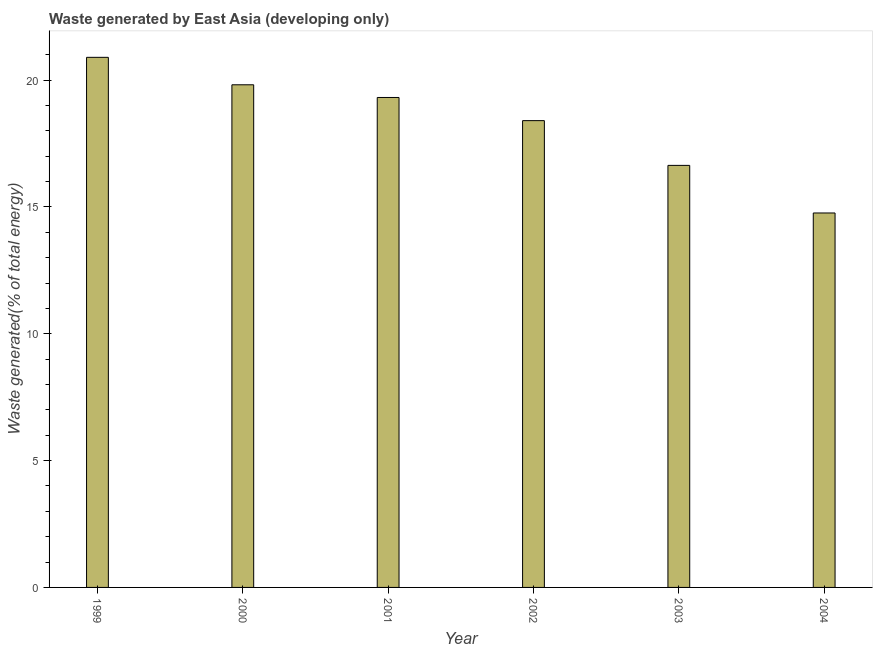What is the title of the graph?
Your response must be concise. Waste generated by East Asia (developing only). What is the label or title of the Y-axis?
Offer a very short reply. Waste generated(% of total energy). What is the amount of waste generated in 2003?
Your response must be concise. 16.64. Across all years, what is the maximum amount of waste generated?
Your response must be concise. 20.9. Across all years, what is the minimum amount of waste generated?
Ensure brevity in your answer.  14.76. In which year was the amount of waste generated maximum?
Your answer should be compact. 1999. What is the sum of the amount of waste generated?
Offer a very short reply. 109.83. What is the difference between the amount of waste generated in 1999 and 2002?
Your answer should be very brief. 2.5. What is the average amount of waste generated per year?
Keep it short and to the point. 18.3. What is the median amount of waste generated?
Your answer should be compact. 18.86. What is the ratio of the amount of waste generated in 2001 to that in 2003?
Your answer should be very brief. 1.16. Is the amount of waste generated in 1999 less than that in 2004?
Offer a terse response. No. What is the difference between the highest and the second highest amount of waste generated?
Provide a short and direct response. 1.08. Is the sum of the amount of waste generated in 2000 and 2003 greater than the maximum amount of waste generated across all years?
Offer a terse response. Yes. What is the difference between the highest and the lowest amount of waste generated?
Your answer should be very brief. 6.14. What is the difference between two consecutive major ticks on the Y-axis?
Your answer should be very brief. 5. Are the values on the major ticks of Y-axis written in scientific E-notation?
Provide a succinct answer. No. What is the Waste generated(% of total energy) of 1999?
Offer a very short reply. 20.9. What is the Waste generated(% of total energy) of 2000?
Your answer should be compact. 19.82. What is the Waste generated(% of total energy) in 2001?
Provide a short and direct response. 19.32. What is the Waste generated(% of total energy) of 2002?
Your answer should be compact. 18.4. What is the Waste generated(% of total energy) of 2003?
Give a very brief answer. 16.64. What is the Waste generated(% of total energy) in 2004?
Provide a short and direct response. 14.76. What is the difference between the Waste generated(% of total energy) in 1999 and 2000?
Provide a succinct answer. 1.08. What is the difference between the Waste generated(% of total energy) in 1999 and 2001?
Provide a short and direct response. 1.58. What is the difference between the Waste generated(% of total energy) in 1999 and 2002?
Keep it short and to the point. 2.5. What is the difference between the Waste generated(% of total energy) in 1999 and 2003?
Provide a succinct answer. 4.26. What is the difference between the Waste generated(% of total energy) in 1999 and 2004?
Keep it short and to the point. 6.14. What is the difference between the Waste generated(% of total energy) in 2000 and 2001?
Your answer should be compact. 0.5. What is the difference between the Waste generated(% of total energy) in 2000 and 2002?
Make the answer very short. 1.41. What is the difference between the Waste generated(% of total energy) in 2000 and 2003?
Make the answer very short. 3.18. What is the difference between the Waste generated(% of total energy) in 2000 and 2004?
Give a very brief answer. 5.05. What is the difference between the Waste generated(% of total energy) in 2001 and 2002?
Ensure brevity in your answer.  0.91. What is the difference between the Waste generated(% of total energy) in 2001 and 2003?
Ensure brevity in your answer.  2.68. What is the difference between the Waste generated(% of total energy) in 2001 and 2004?
Provide a succinct answer. 4.55. What is the difference between the Waste generated(% of total energy) in 2002 and 2003?
Ensure brevity in your answer.  1.76. What is the difference between the Waste generated(% of total energy) in 2002 and 2004?
Provide a short and direct response. 3.64. What is the difference between the Waste generated(% of total energy) in 2003 and 2004?
Offer a very short reply. 1.88. What is the ratio of the Waste generated(% of total energy) in 1999 to that in 2000?
Your response must be concise. 1.05. What is the ratio of the Waste generated(% of total energy) in 1999 to that in 2001?
Give a very brief answer. 1.08. What is the ratio of the Waste generated(% of total energy) in 1999 to that in 2002?
Ensure brevity in your answer.  1.14. What is the ratio of the Waste generated(% of total energy) in 1999 to that in 2003?
Your response must be concise. 1.26. What is the ratio of the Waste generated(% of total energy) in 1999 to that in 2004?
Provide a short and direct response. 1.42. What is the ratio of the Waste generated(% of total energy) in 2000 to that in 2001?
Offer a very short reply. 1.03. What is the ratio of the Waste generated(% of total energy) in 2000 to that in 2002?
Your response must be concise. 1.08. What is the ratio of the Waste generated(% of total energy) in 2000 to that in 2003?
Your answer should be very brief. 1.19. What is the ratio of the Waste generated(% of total energy) in 2000 to that in 2004?
Keep it short and to the point. 1.34. What is the ratio of the Waste generated(% of total energy) in 2001 to that in 2002?
Offer a terse response. 1.05. What is the ratio of the Waste generated(% of total energy) in 2001 to that in 2003?
Provide a succinct answer. 1.16. What is the ratio of the Waste generated(% of total energy) in 2001 to that in 2004?
Ensure brevity in your answer.  1.31. What is the ratio of the Waste generated(% of total energy) in 2002 to that in 2003?
Ensure brevity in your answer.  1.11. What is the ratio of the Waste generated(% of total energy) in 2002 to that in 2004?
Keep it short and to the point. 1.25. What is the ratio of the Waste generated(% of total energy) in 2003 to that in 2004?
Your answer should be compact. 1.13. 